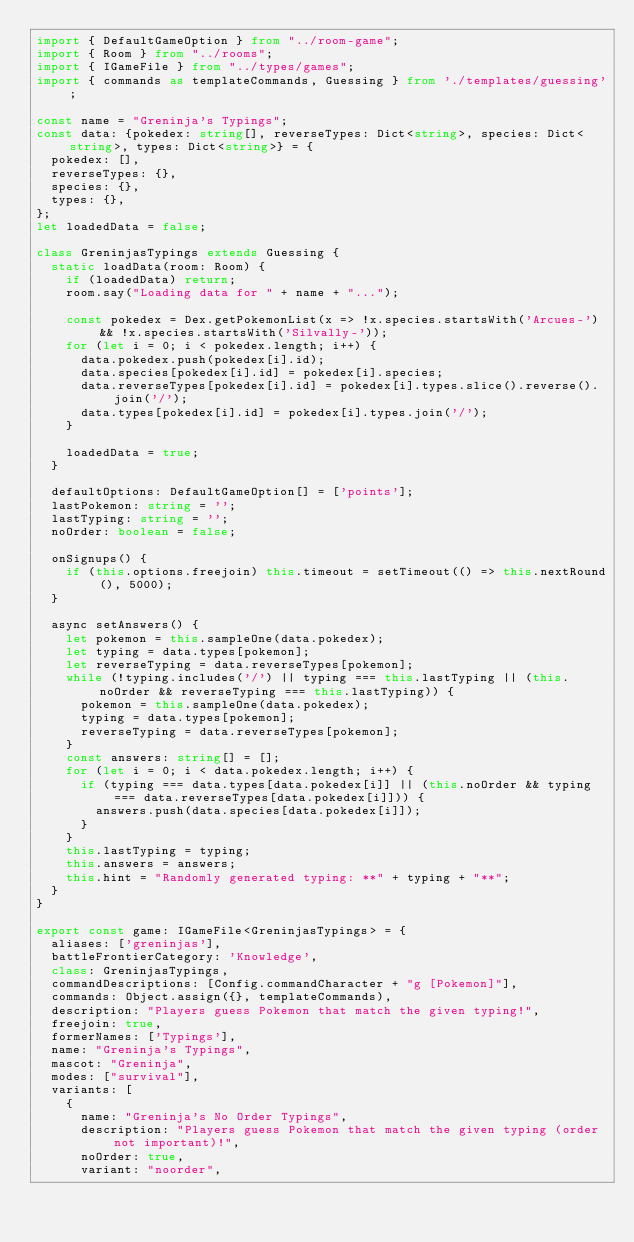Convert code to text. <code><loc_0><loc_0><loc_500><loc_500><_TypeScript_>import { DefaultGameOption } from "../room-game";
import { Room } from "../rooms";
import { IGameFile } from "../types/games";
import { commands as templateCommands, Guessing } from './templates/guessing';

const name = "Greninja's Typings";
const data: {pokedex: string[], reverseTypes: Dict<string>, species: Dict<string>, types: Dict<string>} = {
	pokedex: [],
	reverseTypes: {},
	species: {},
	types: {},
};
let loadedData = false;

class GreninjasTypings extends Guessing {
	static loadData(room: Room) {
		if (loadedData) return;
		room.say("Loading data for " + name + "...");

		const pokedex = Dex.getPokemonList(x => !x.species.startsWith('Arcues-') && !x.species.startsWith('Silvally-'));
		for (let i = 0; i < pokedex.length; i++) {
			data.pokedex.push(pokedex[i].id);
			data.species[pokedex[i].id] = pokedex[i].species;
			data.reverseTypes[pokedex[i].id] = pokedex[i].types.slice().reverse().join('/');
			data.types[pokedex[i].id] = pokedex[i].types.join('/');
		}

		loadedData = true;
	}

	defaultOptions: DefaultGameOption[] = ['points'];
	lastPokemon: string = '';
	lastTyping: string = '';
	noOrder: boolean = false;

	onSignups() {
		if (this.options.freejoin) this.timeout = setTimeout(() => this.nextRound(), 5000);
	}

	async setAnswers() {
		let pokemon = this.sampleOne(data.pokedex);
		let typing = data.types[pokemon];
		let reverseTyping = data.reverseTypes[pokemon];
		while (!typing.includes('/') || typing === this.lastTyping || (this.noOrder && reverseTyping === this.lastTyping)) {
			pokemon = this.sampleOne(data.pokedex);
			typing = data.types[pokemon];
			reverseTyping = data.reverseTypes[pokemon];
		}
		const answers: string[] = [];
		for (let i = 0; i < data.pokedex.length; i++) {
			if (typing === data.types[data.pokedex[i]] || (this.noOrder && typing === data.reverseTypes[data.pokedex[i]])) {
				answers.push(data.species[data.pokedex[i]]);
			}
		}
		this.lastTyping = typing;
		this.answers = answers;
		this.hint = "Randomly generated typing: **" + typing + "**";
	}
}

export const game: IGameFile<GreninjasTypings> = {
	aliases: ['greninjas'],
	battleFrontierCategory: 'Knowledge',
	class: GreninjasTypings,
	commandDescriptions: [Config.commandCharacter + "g [Pokemon]"],
	commands: Object.assign({}, templateCommands),
	description: "Players guess Pokemon that match the given typing!",
	freejoin: true,
	formerNames: ['Typings'],
	name: "Greninja's Typings",
	mascot: "Greninja",
	modes: ["survival"],
	variants: [
		{
			name: "Greninja's No Order Typings",
			description: "Players guess Pokemon that match the given typing (order not important)!",
			noOrder: true,
			variant: "noorder",</code> 